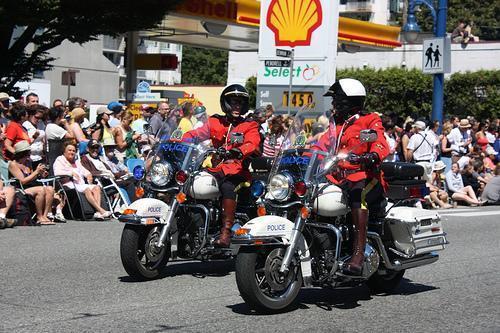What do the people seated by the road await?
From the following four choices, select the correct answer to address the question.
Options: Racing, nothing, parade, arrest. Parade. 